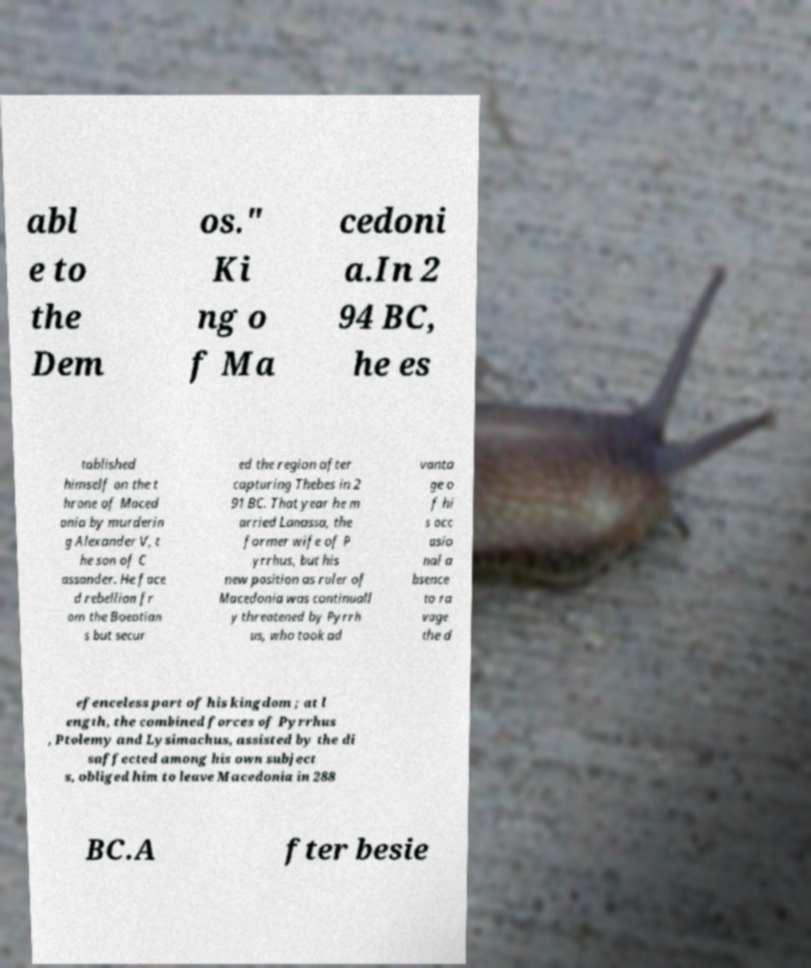Please identify and transcribe the text found in this image. abl e to the Dem os." Ki ng o f Ma cedoni a.In 2 94 BC, he es tablished himself on the t hrone of Maced onia by murderin g Alexander V, t he son of C assander. He face d rebellion fr om the Boeotian s but secur ed the region after capturing Thebes in 2 91 BC. That year he m arried Lanassa, the former wife of P yrrhus, but his new position as ruler of Macedonia was continuall y threatened by Pyrrh us, who took ad vanta ge o f hi s occ asio nal a bsence to ra vage the d efenceless part of his kingdom ; at l ength, the combined forces of Pyrrhus , Ptolemy and Lysimachus, assisted by the di saffected among his own subject s, obliged him to leave Macedonia in 288 BC.A fter besie 